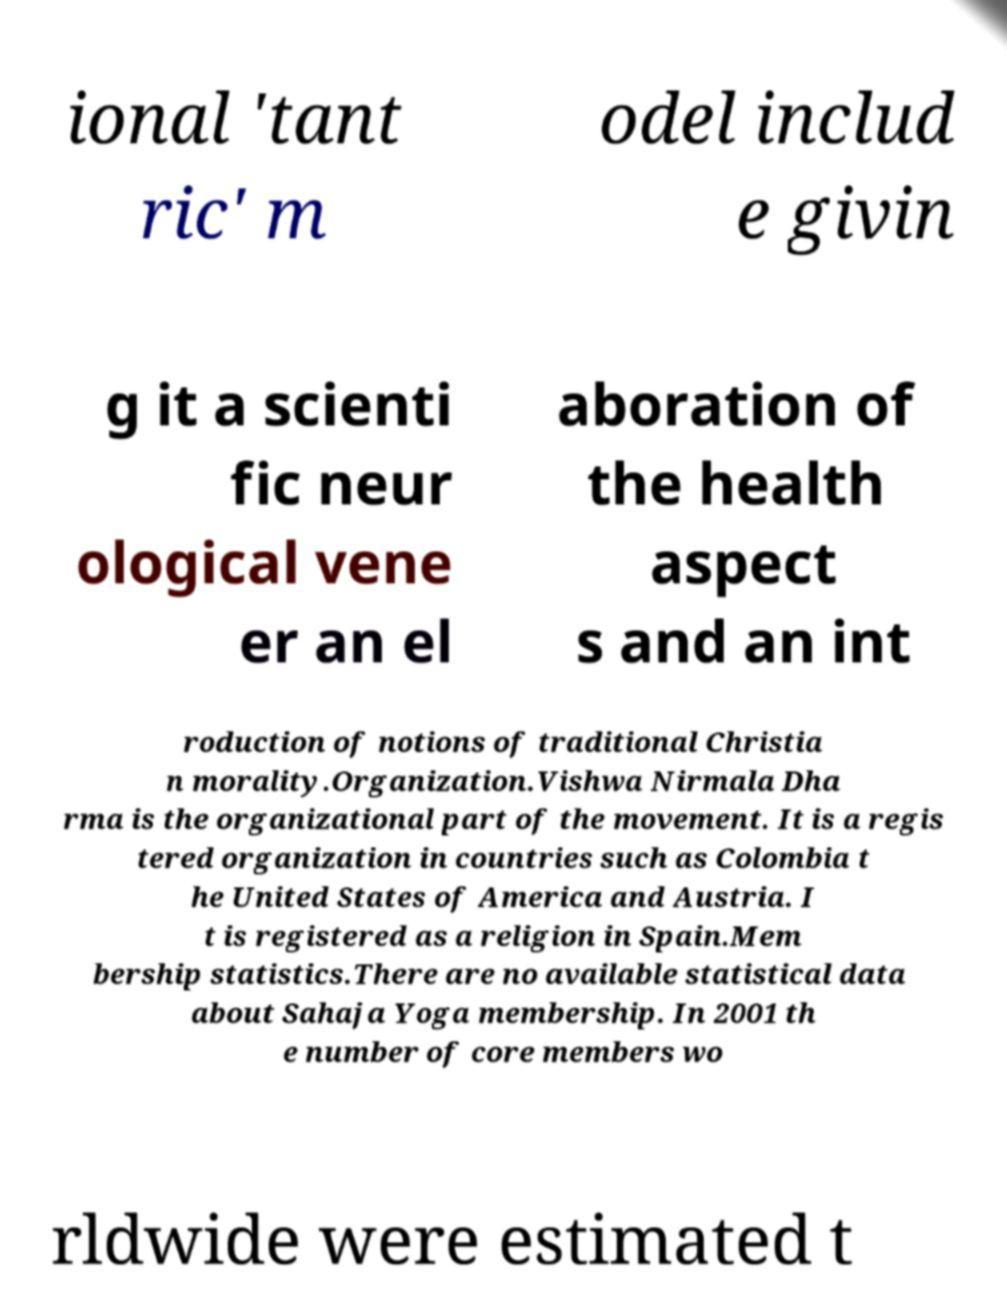Can you accurately transcribe the text from the provided image for me? ional 'tant ric' m odel includ e givin g it a scienti fic neur ological vene er an el aboration of the health aspect s and an int roduction of notions of traditional Christia n morality.Organization.Vishwa Nirmala Dha rma is the organizational part of the movement. It is a regis tered organization in countries such as Colombia t he United States of America and Austria. I t is registered as a religion in Spain.Mem bership statistics.There are no available statistical data about Sahaja Yoga membership. In 2001 th e number of core members wo rldwide were estimated t 